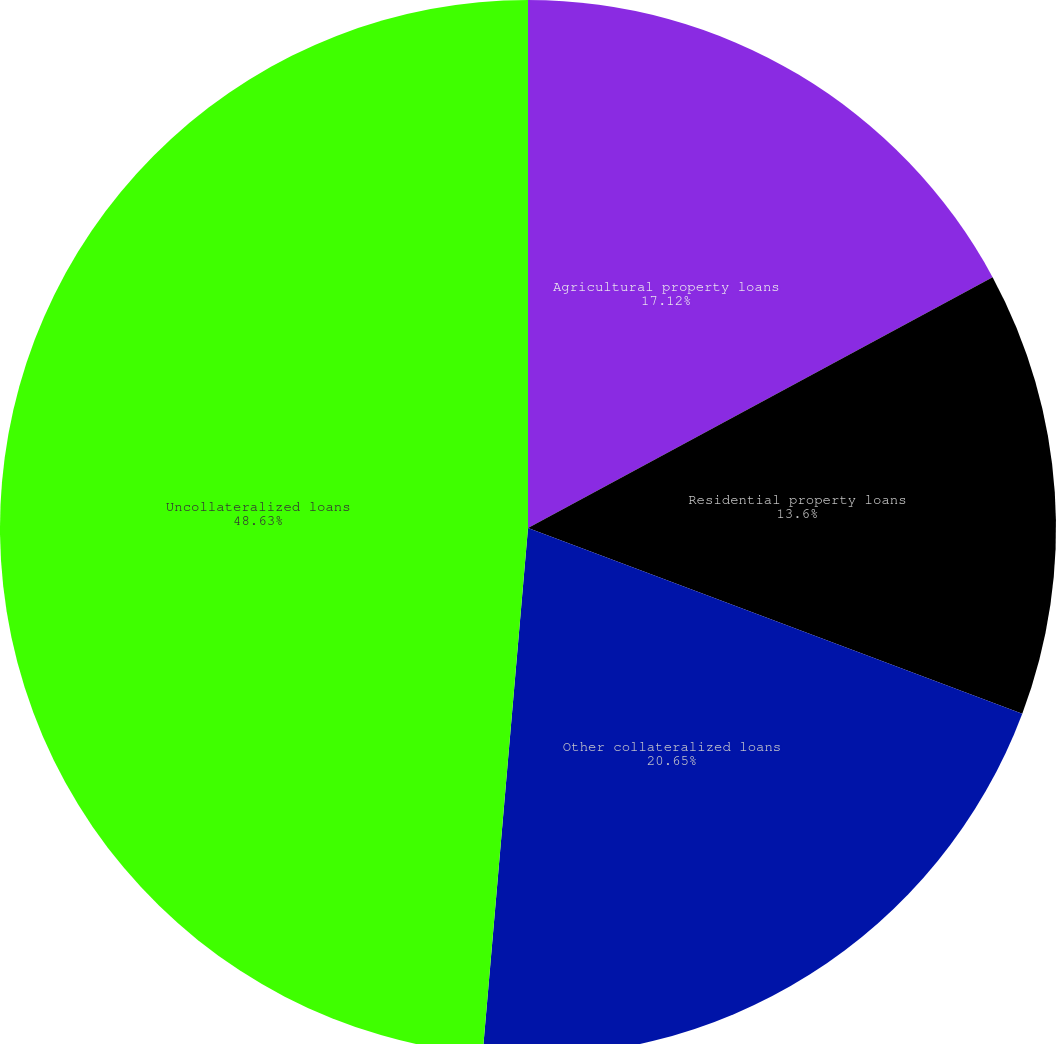Convert chart. <chart><loc_0><loc_0><loc_500><loc_500><pie_chart><fcel>Agricultural property loans<fcel>Residential property loans<fcel>Other collateralized loans<fcel>Uncollateralized loans<nl><fcel>17.12%<fcel>13.6%<fcel>20.65%<fcel>48.63%<nl></chart> 